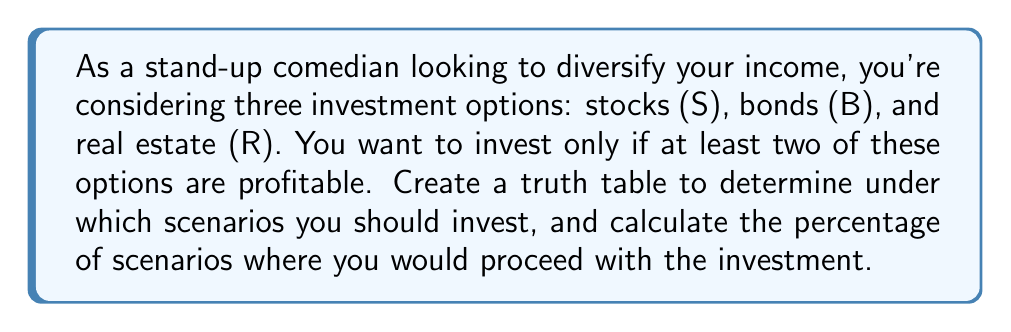Can you answer this question? Let's approach this step-by-step:

1) First, we need to create a truth table with three variables: S, B, and R.
   Each can be either true (1) or false (0), representing profitability.

2) We'll add a column I for the investment decision, which will be true (1) if at least two options are profitable.

3) Here's the truth table:

   S | B | R | I
   ---------------
   0 | 0 | 0 | 0
   0 | 0 | 1 | 0
   0 | 1 | 0 | 0
   0 | 1 | 1 | 1
   1 | 0 | 0 | 0
   1 | 0 | 1 | 1
   1 | 1 | 0 | 1
   1 | 1 | 1 | 1

4) To determine I, we use the Boolean function:
   $I = (S \land B) \lor (S \land R) \lor (B \land R)$

5) To calculate the percentage of scenarios where you would invest:
   - Total number of scenarios: $2^3 = 8$
   - Number of scenarios where I = 1: 4
   - Percentage = $\frac{4}{8} \times 100\% = 50\%$

Therefore, you would proceed with the investment in 50% of the scenarios.
Answer: 50% 